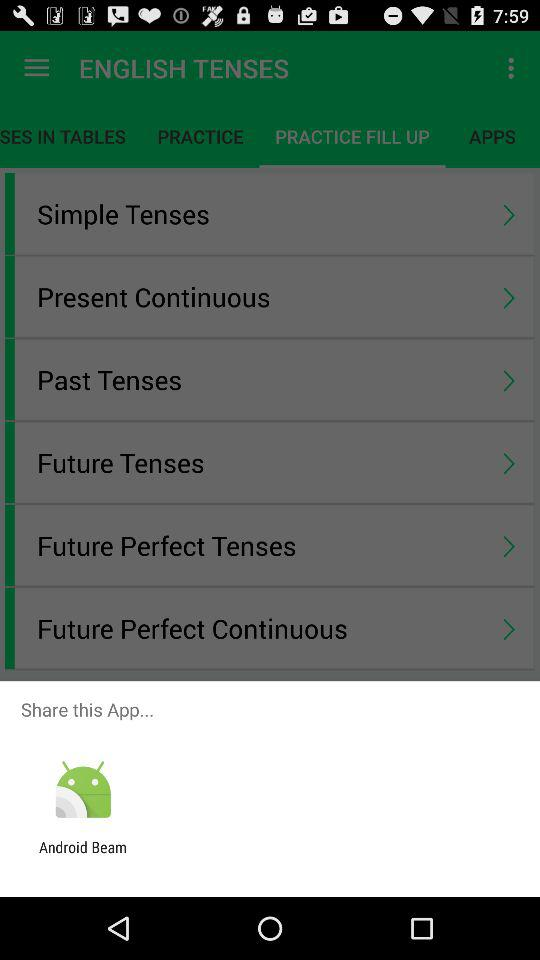What are the apps that can be used to share the app? The app that can be used to share the app is "Android Beam". 